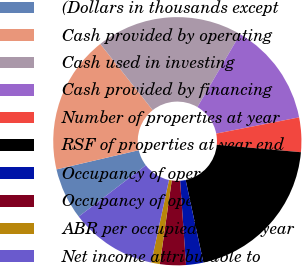Convert chart. <chart><loc_0><loc_0><loc_500><loc_500><pie_chart><fcel>(Dollars in thousands except<fcel>Cash provided by operating<fcel>Cash used in investing<fcel>Cash provided by financing<fcel>Number of properties at year<fcel>RSF of properties at year end<fcel>Occupancy of operating<fcel>Occupancy of operating and<fcel>ABR per occupied RSF at year<fcel>Net income attributable to<nl><fcel>6.74%<fcel>17.98%<fcel>19.1%<fcel>13.48%<fcel>4.49%<fcel>20.22%<fcel>2.25%<fcel>3.37%<fcel>1.12%<fcel>11.24%<nl></chart> 